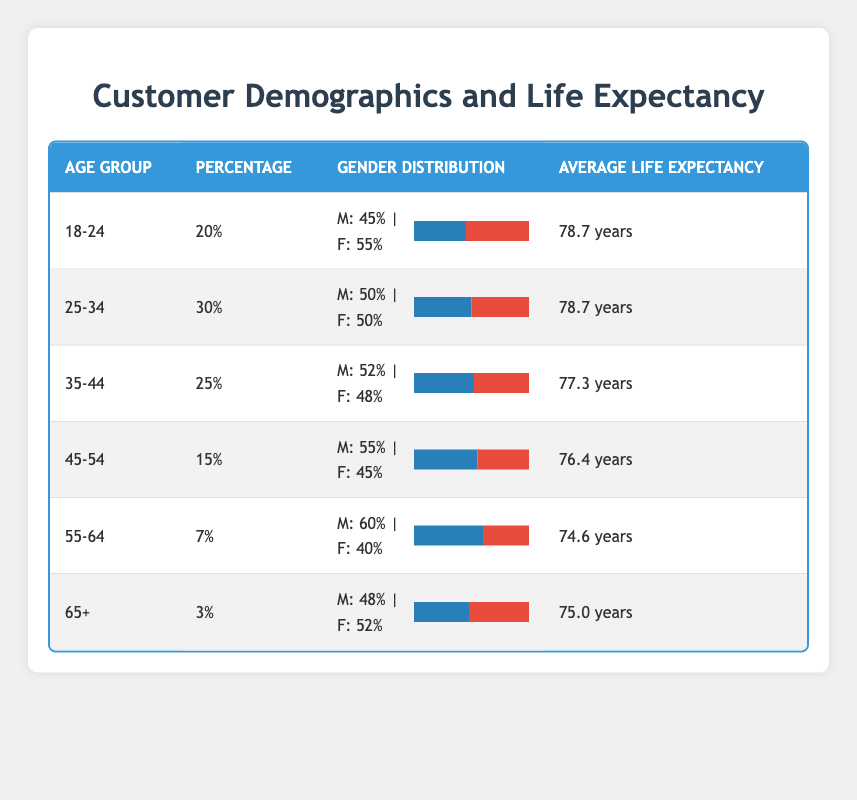What is the average life expectancy for the age group 25-34? The average life expectancy for the age group 25-34 is listed directly in the table under the corresponding row, showing 78.7 years.
Answer: 78.7 years Which age group has the highest percentage? The highest percentage is found in the 25-34 age group, where it is noted as 30%.
Answer: 25-34 age group Does the age group 45-54 have a higher life expectancy than the age group 35-44? The life expectancy for the age group 45-54 is 76.4 years, while for the age group 35-44, it is 77.3 years. Since 76.4 is less than 77.3, the age group 45-54 does not have a higher life expectancy.
Answer: No What is the percentage total for the age groups 55-64 and 65+ combined? The percentage of the age group 55-64 is 7% and for the age group 65+, it is 3%. Adding these percentages together gives 7% + 3% = 10%.
Answer: 10% Is the gender distribution in the 18-24 age group skewed more towards females or males? The gender distribution for the 18-24 age group shows 55% female and 45% male. Since 55% is greater than 45%, this indicates a skew towards females.
Answer: Yes Which age group has the lowest average life expectancy? By examining the average life expectancy values listed in the table, the lowest is found in the age group 55-64, with an average life expectancy of 74.6 years.
Answer: 55-64 age group What is the difference in average life expectancy between the age groups 18-24 and 45-54? The average life expectancy for 18-24 is 78.7 years and for 45-54 is 76.4 years. To find the difference, subtract 76.4 from 78.7, which gives 78.7 - 76.4 = 2.3 years.
Answer: 2.3 years If you combine all percentage groups, what is the total percentage represented? The total percentage is calculated by adding all the individual age group percentages together: 20% + 30% + 25% + 15% + 7% + 3% = 100%.
Answer: 100% Does the male gender distribution exceed the female gender distribution for the age group 55-64? For the age group 55-64, the male percentage is 60% and the female is 40%. Since 60% is greater than 40%, the male gender does exceed the female gender distribution in this group.
Answer: Yes 